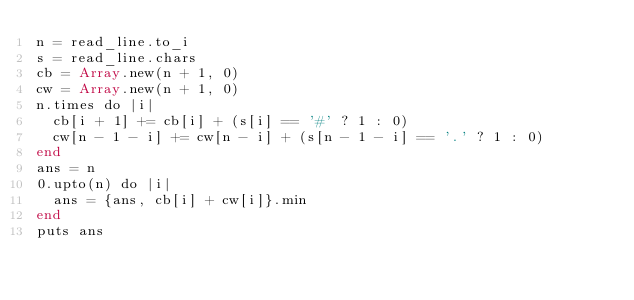<code> <loc_0><loc_0><loc_500><loc_500><_Crystal_>n = read_line.to_i
s = read_line.chars
cb = Array.new(n + 1, 0)
cw = Array.new(n + 1, 0)
n.times do |i|
  cb[i + 1] += cb[i] + (s[i] == '#' ? 1 : 0)
  cw[n - 1 - i] += cw[n - i] + (s[n - 1 - i] == '.' ? 1 : 0)
end
ans = n
0.upto(n) do |i|
  ans = {ans, cb[i] + cw[i]}.min
end
puts ans
</code> 